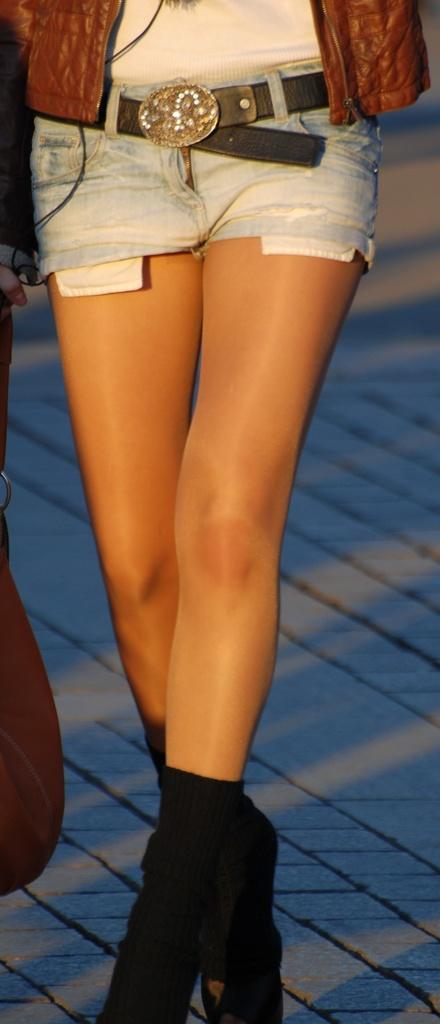How would you summarize this image in a sentence or two? A person is standing wearing shorts, black boots and brown jacket. 